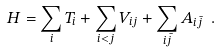Convert formula to latex. <formula><loc_0><loc_0><loc_500><loc_500>H = \sum _ { i } T _ { i } + \sum _ { i < j } V _ { i j } + \sum _ { i \bar { j } } A _ { i \bar { j } } \ .</formula> 